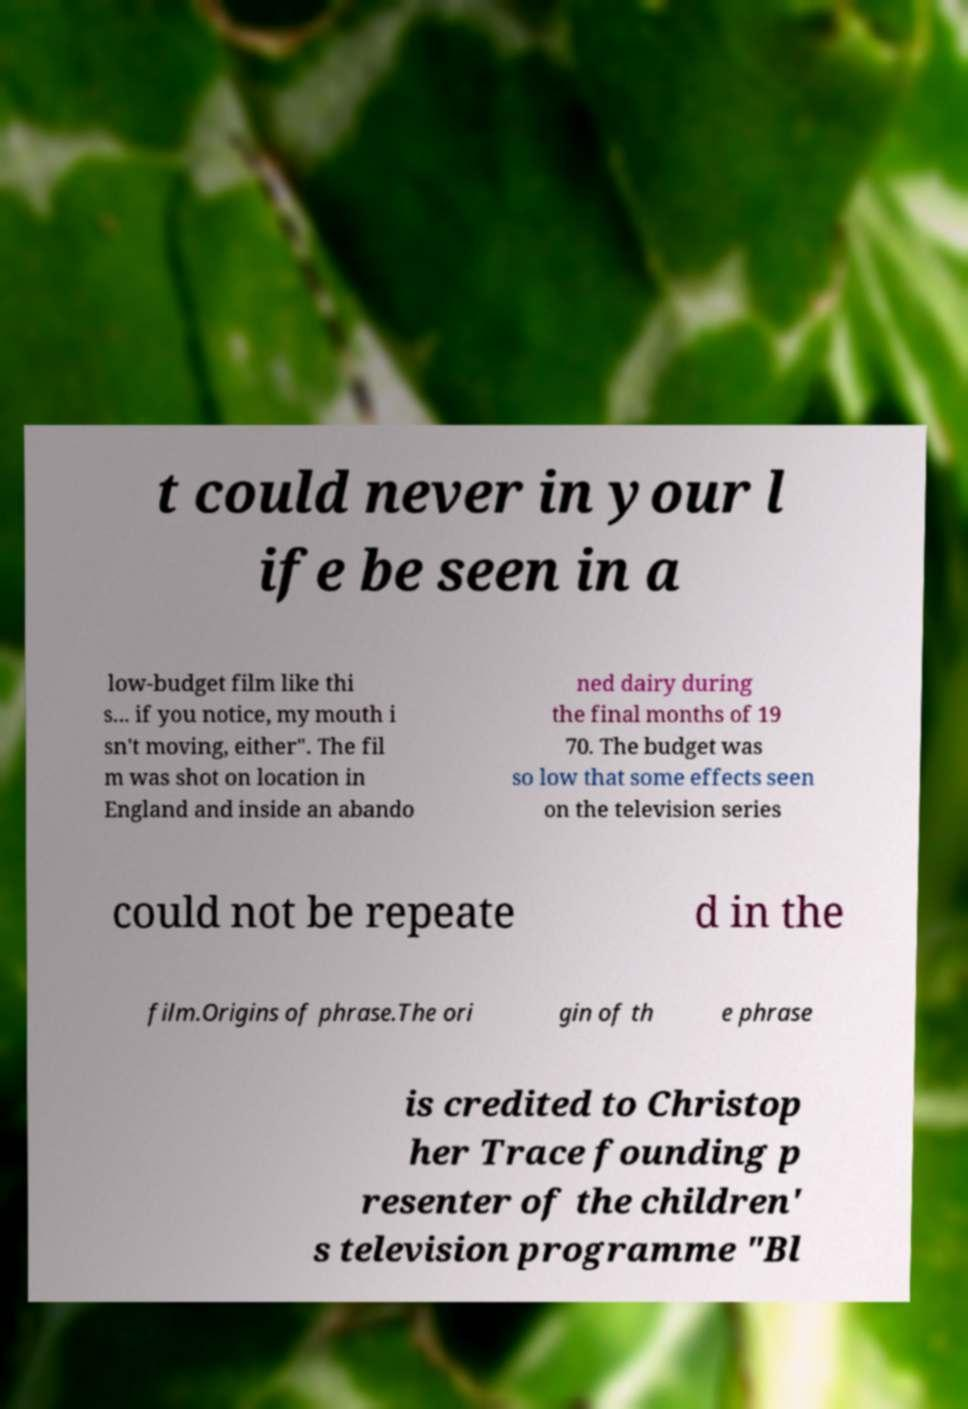Could you assist in decoding the text presented in this image and type it out clearly? t could never in your l ife be seen in a low-budget film like thi s... if you notice, my mouth i sn't moving, either". The fil m was shot on location in England and inside an abando ned dairy during the final months of 19 70. The budget was so low that some effects seen on the television series could not be repeate d in the film.Origins of phrase.The ori gin of th e phrase is credited to Christop her Trace founding p resenter of the children' s television programme "Bl 